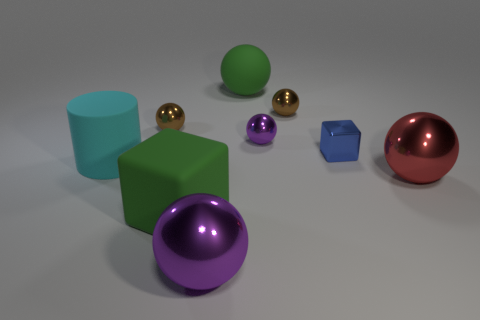Subtract all small brown balls. How many balls are left? 4 Subtract all blue blocks. How many blocks are left? 1 Subtract 5 balls. How many balls are left? 1 Add 1 large red things. How many objects exist? 10 Subtract all spheres. How many objects are left? 3 Add 3 cyan cylinders. How many cyan cylinders exist? 4 Subtract 0 red cylinders. How many objects are left? 9 Subtract all brown blocks. Subtract all green cylinders. How many blocks are left? 2 Subtract all green spheres. How many purple cylinders are left? 0 Subtract all large gray metallic objects. Subtract all tiny metallic blocks. How many objects are left? 8 